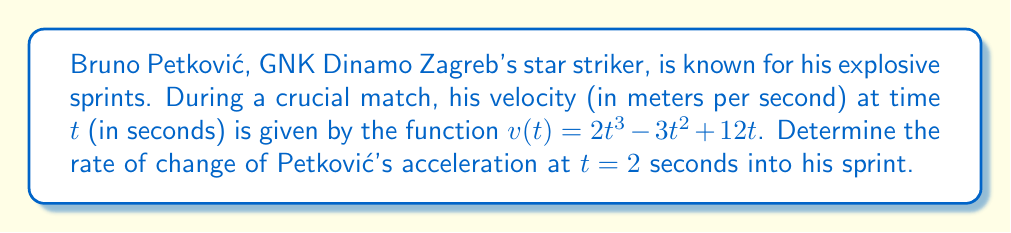Teach me how to tackle this problem. To solve this problem, we need to follow these steps:

1) First, we need to find the acceleration function. Acceleration is the derivative of velocity with respect to time.

   $a(t) = \frac{d}{dt}v(t) = \frac{d}{dt}(2t^3 - 3t^2 + 12t)$
   
   $a(t) = 6t^2 - 6t + 12$

2) Now, we need to find the rate of change of acceleration. This is the derivative of acceleration with respect to time, also known as jerk.

   $j(t) = \frac{d}{dt}a(t) = \frac{d}{dt}(6t^2 - 6t + 12)$
   
   $j(t) = 12t - 6$

3) The question asks for the rate of change of acceleration at $t = 2$ seconds. We simply need to evaluate $j(t)$ at $t = 2$.

   $j(2) = 12(2) - 6 = 24 - 6 = 18$

Therefore, the rate of change of Petković's acceleration at 2 seconds into his sprint is 18 m/s³.
Answer: 18 m/s³ 